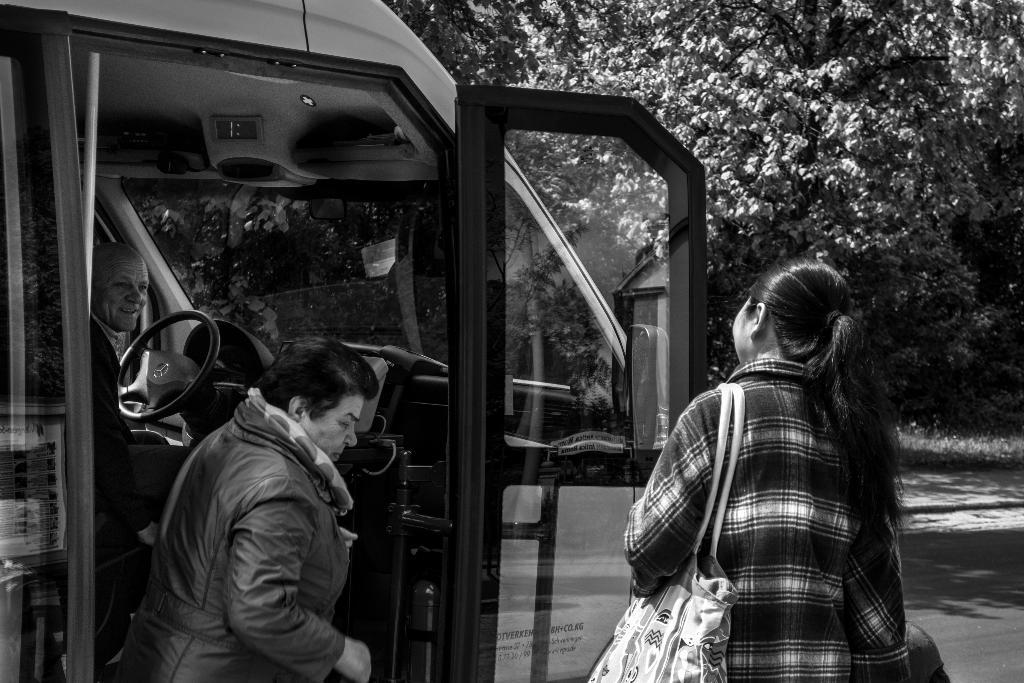What is the main subject of the image? The main subject of the image is a person visible in a vehicle. Are there any other people visible in the image? Yes, there are two persons visible in front of the vehicle. What can be seen in the top right corner of the image? There is a plant visible in the top right corner of the image. What type of humor can be seen in the image? There is no humor present in the image; it is a straightforward depiction of a person in a vehicle and two people in front of the vehicle. 